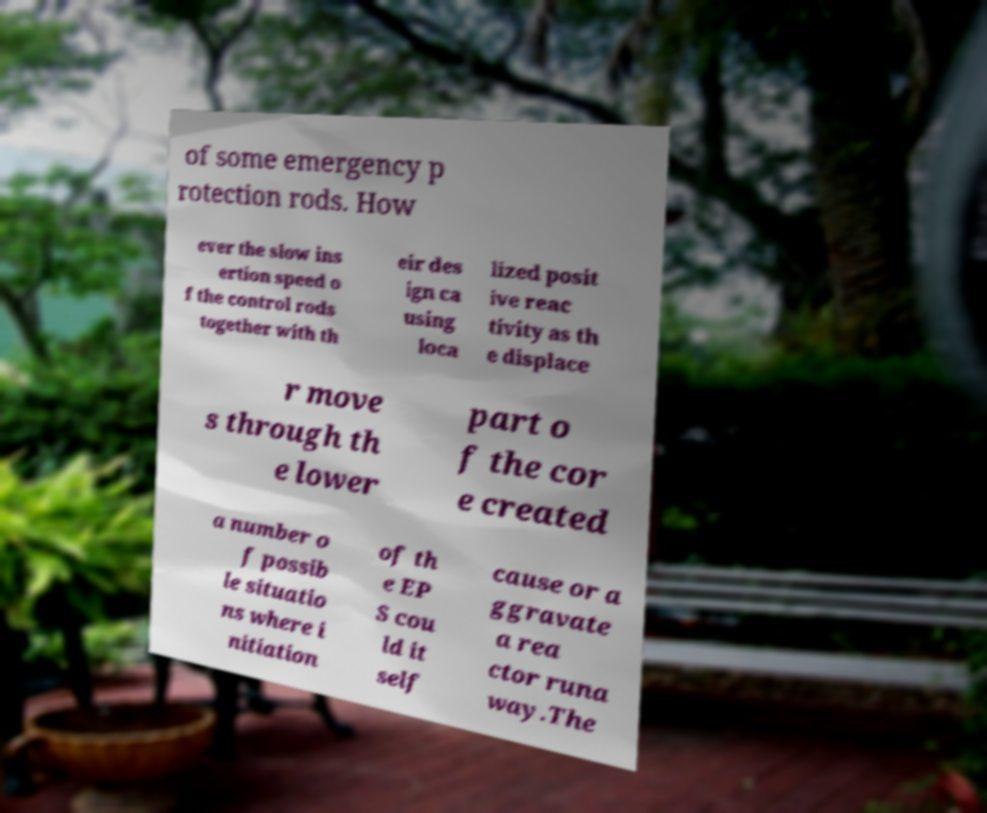I need the written content from this picture converted into text. Can you do that? of some emergency p rotection rods. How ever the slow ins ertion speed o f the control rods together with th eir des ign ca using loca lized posit ive reac tivity as th e displace r move s through th e lower part o f the cor e created a number o f possib le situatio ns where i nitiation of th e EP S cou ld it self cause or a ggravate a rea ctor runa way.The 